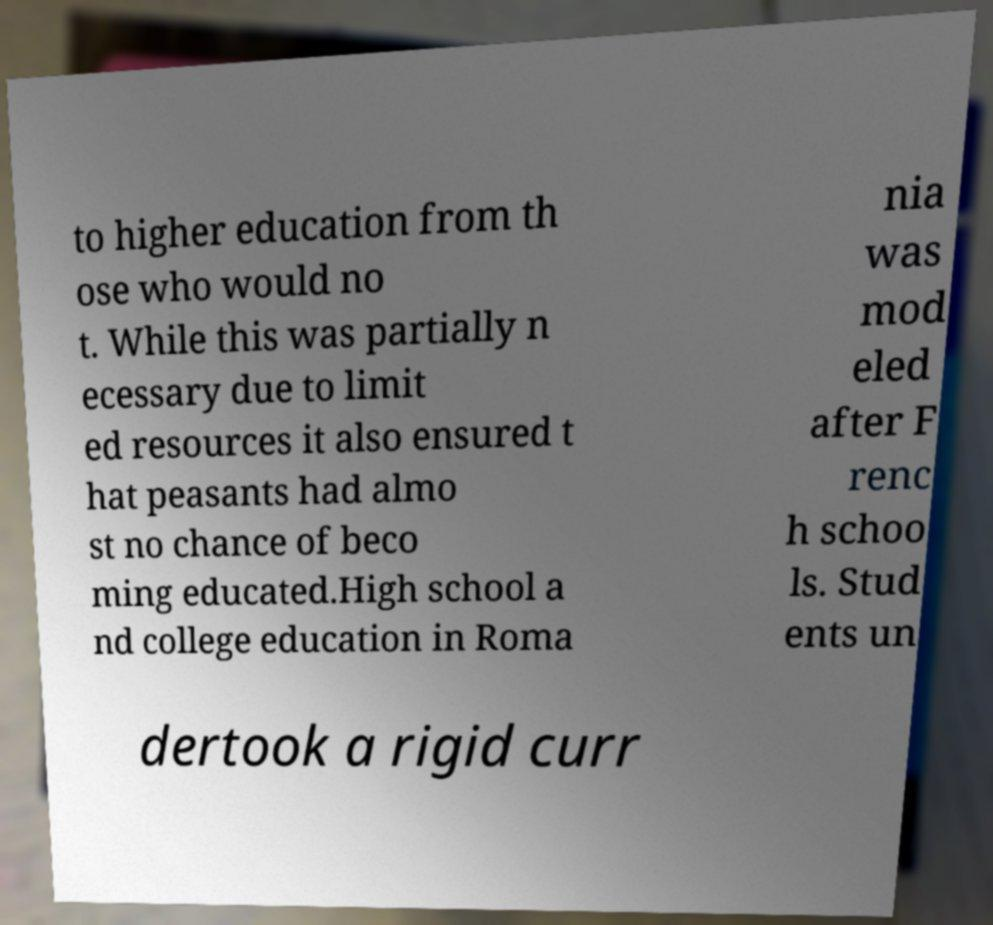Please identify and transcribe the text found in this image. to higher education from th ose who would no t. While this was partially n ecessary due to limit ed resources it also ensured t hat peasants had almo st no chance of beco ming educated.High school a nd college education in Roma nia was mod eled after F renc h schoo ls. Stud ents un dertook a rigid curr 